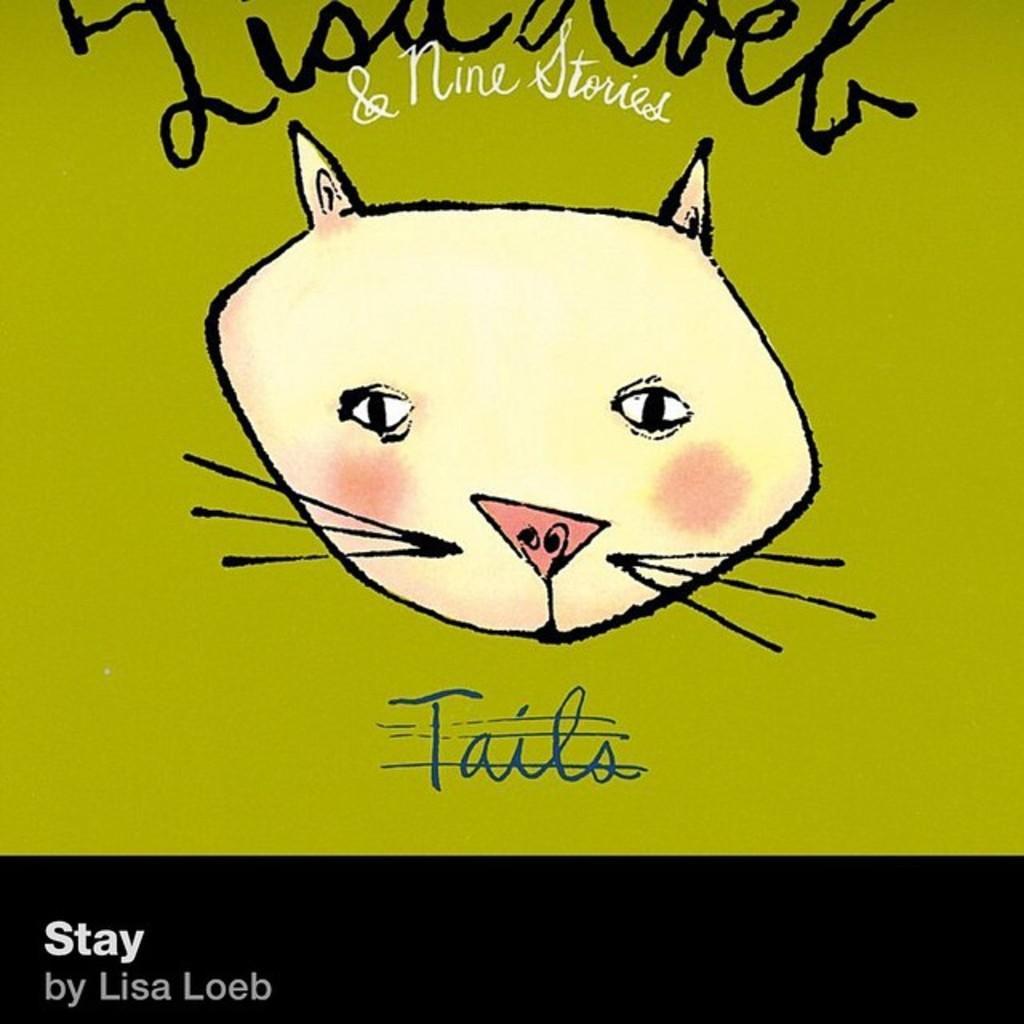Can you describe this image briefly? In this image there is a drawing of face of an animal and there is some text written on it. 